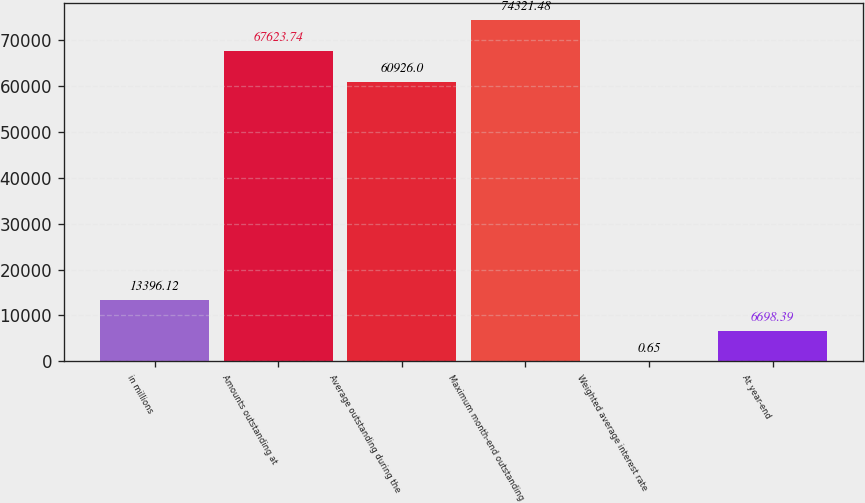<chart> <loc_0><loc_0><loc_500><loc_500><bar_chart><fcel>in millions<fcel>Amounts outstanding at<fcel>Average outstanding during the<fcel>Maximum month-end outstanding<fcel>Weighted average interest rate<fcel>At year-end<nl><fcel>13396.1<fcel>67623.7<fcel>60926<fcel>74321.5<fcel>0.65<fcel>6698.39<nl></chart> 